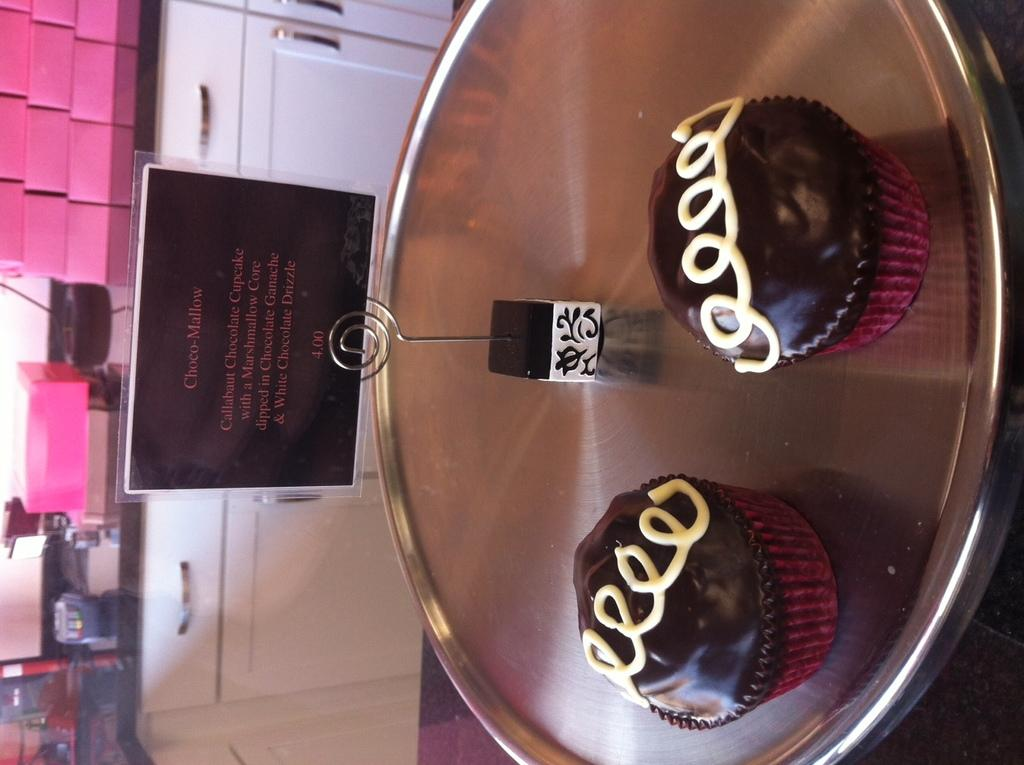<image>
Render a clear and concise summary of the photo. two pretty cupcakes on display next to a sign saying Choco-Mallow 